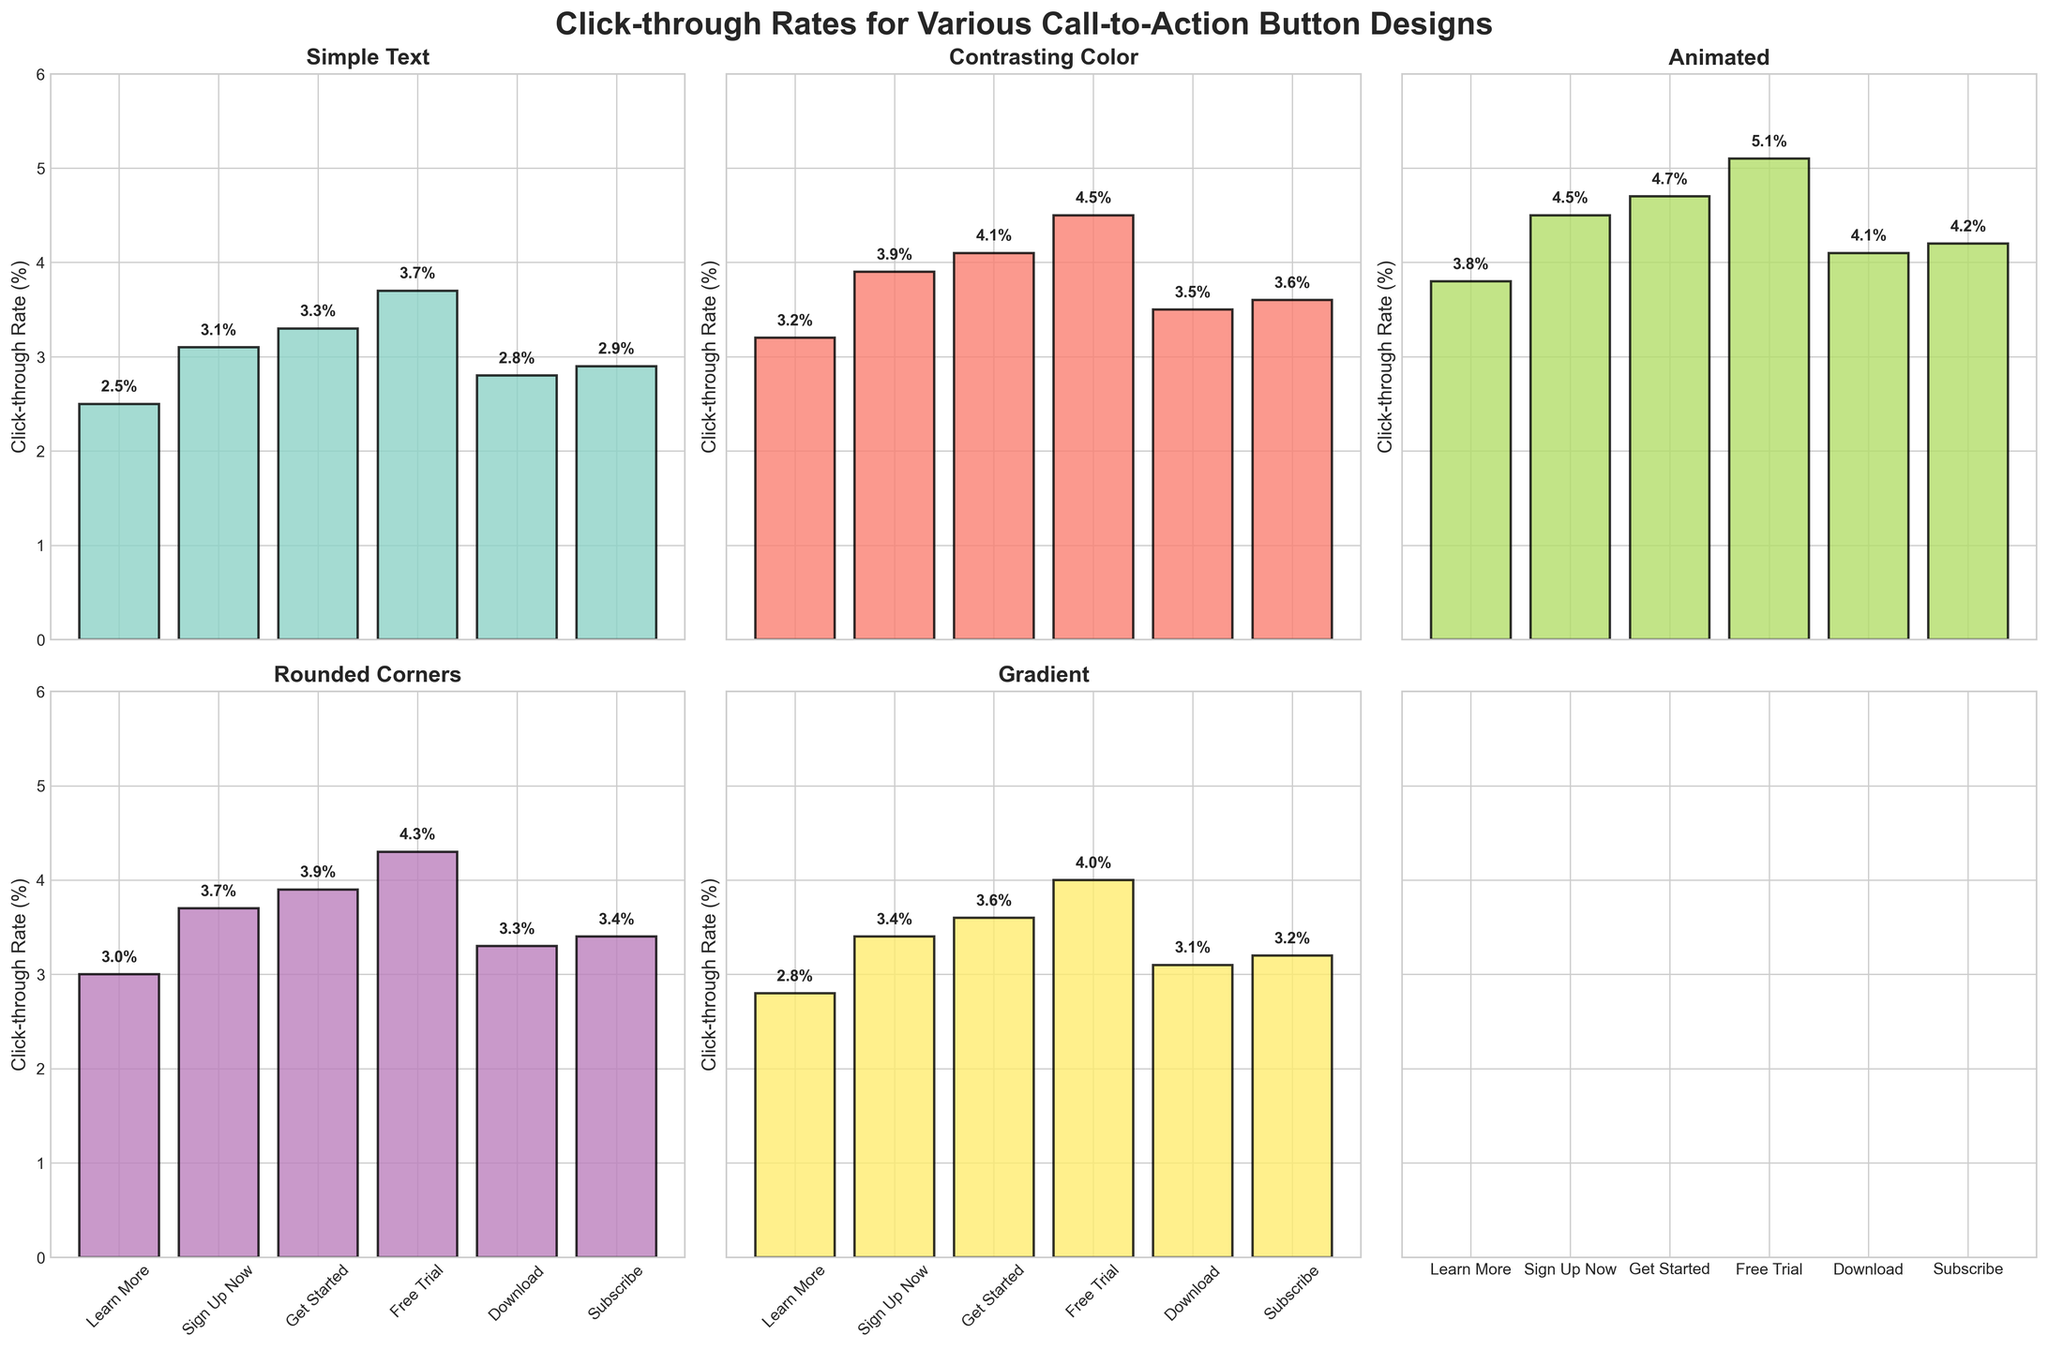How many subplots are there in the figure? The figure is divided into a 2x3 grid of subplots, meaning there are 2 rows and 3 columns of individual plots.
Answer: 6 What is the highest click-through rate for the 'Sign Up Now' button across all design types? For 'Sign Up Now,' the highest click-through rate is shown under the 'Animated' design type. The corresponding value is 4.5%.
Answer: 4.5% Which button design generally has the highest click-through rates across all design types? By examining the heights of the bars across all subplots, 'Free Trial' generally has the highest click-through rates in each design type.
Answer: 'Free Trial' On average, how does the click-through rate of 'Rounded Corners' compare to 'Simple Text'? To find the average click-through rate for each design type, sum the values for each button design and divide by the number of button designs: \('Rounded Corners'\): (3.0 + 3.7 + 3.9 + 4.3 + 3.3 + 3.4)/6 = 3.77% \('Simple Text'\): (2.5 + 3.1 + 3.3 + 3.7 + 2.8 + 2.9)/6 = 3.05% \(\ 3.77% > 3.05%\)
Answer: 'Rounded Corners' has a higher average Which design type has the least variation in click-through rates? The variation can be visually assessed from the bar plots. 'Simple Text' has the smallest differences in bar heights within its subplot compared to the others.
Answer: 'Simple Text' What is the click-through rate for the 'Download' button in the 'Gradient' design type? For the 'Download' button, refer to the bar height in the 'Gradient' design type subplot; it is 3.1%.
Answer: 3.1% Which two button designs have the closest click-through rates in the 'Contrasting Color' design type? By comparing the bar heights in the 'Contrasting Color' subplot, 'Download' and 'Subscribe' have rates of 3.5% and 3.6%, respectively, which are the closest.
Answer: 'Download' and 'Subscribe' What is the click-through rate difference between 'Get Started' and 'Free Trial' for the 'Animated' design type? The click-through rates for 'Get Started' and 'Free Trial' in 'Animated' are 4.7% and 5.1%, respectively. The difference is 5.1% - 4.7% = 0.4%.
Answer: 0.4% 